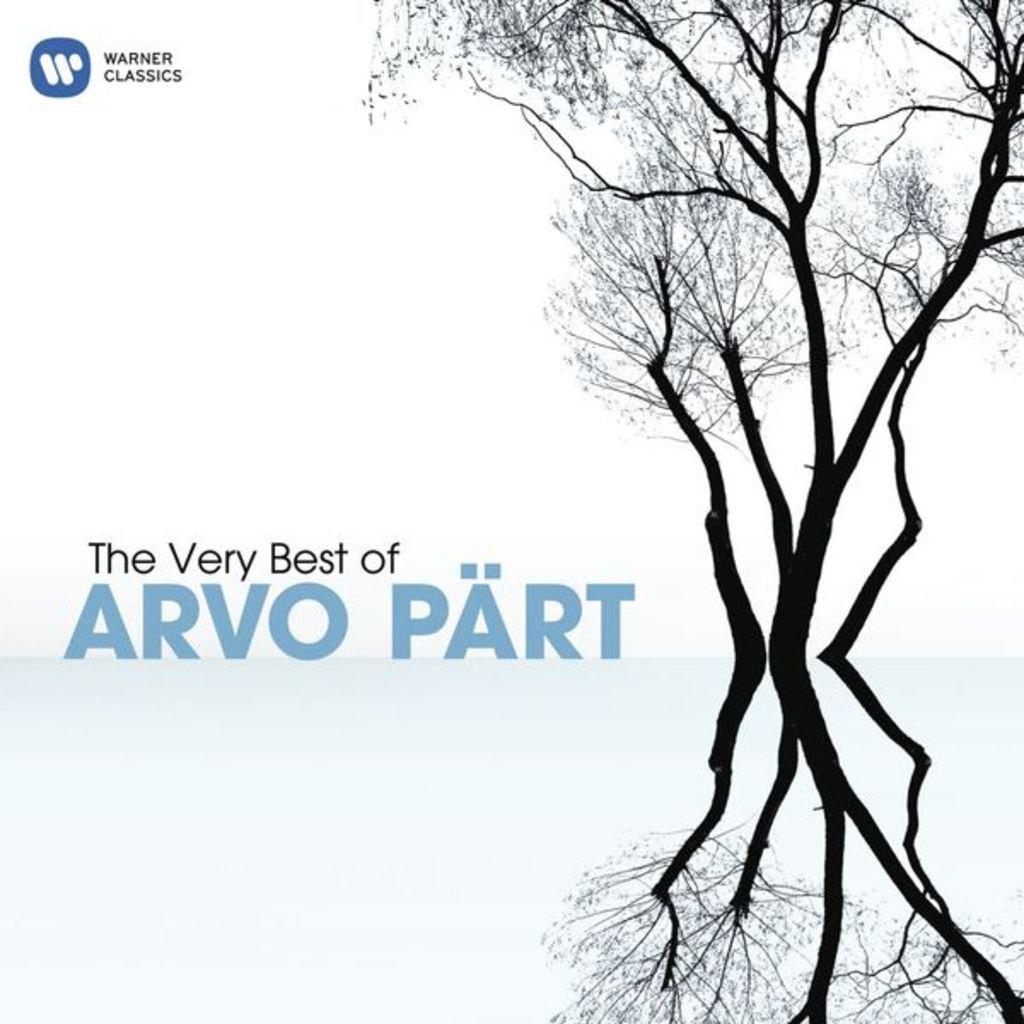What type of visual is the image? The image is a poster. What natural elements can be seen in the poster? There are trees visible in the image. What else is featured on the poster besides the trees? There is text present in the image. What type of stew is being served in the image? There is no stew present in the image; it is a poster featuring trees and text. What government policy is being discussed in the image? There is no discussion of government policy in the image; it is a poster featuring trees and text. 